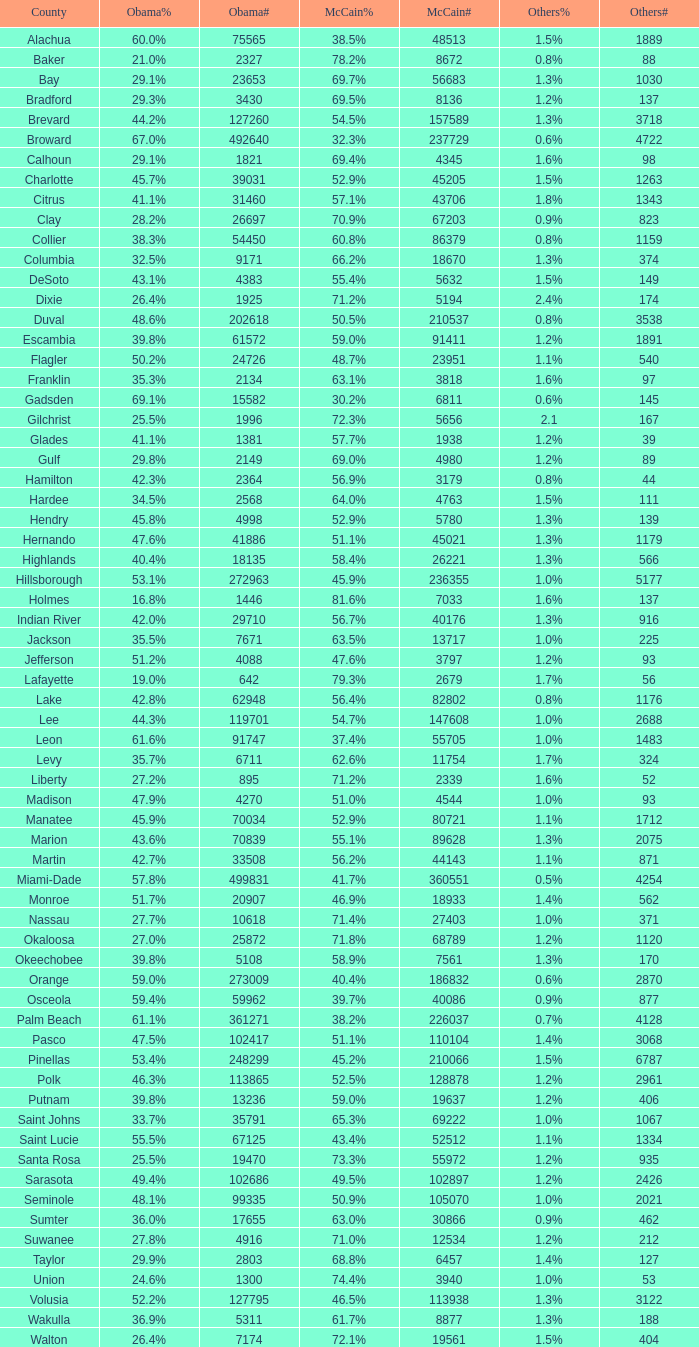What fraction was the other's vote when mccain got 5 1.3%. 